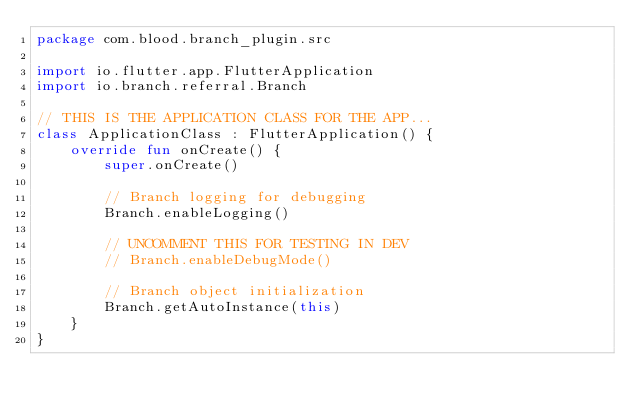<code> <loc_0><loc_0><loc_500><loc_500><_Kotlin_>package com.blood.branch_plugin.src

import io.flutter.app.FlutterApplication
import io.branch.referral.Branch

// THIS IS THE APPLICATION CLASS FOR THE APP...
class ApplicationClass : FlutterApplication() {
    override fun onCreate() {
        super.onCreate()

        // Branch logging for debugging
        Branch.enableLogging()

        // UNCOMMENT THIS FOR TESTING IN DEV
        // Branch.enableDebugMode()

        // Branch object initialization
        Branch.getAutoInstance(this)
    }
}</code> 